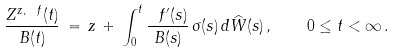Convert formula to latex. <formula><loc_0><loc_0><loc_500><loc_500>\frac { Z ^ { z , \ f } ( t ) } { B ( t ) } \, = \, z \, + \, \int _ { 0 } ^ { t } \frac { \ f ^ { \prime } ( s ) } { B ( s ) } \, \sigma ( s ) \, d \widehat { W } ( s ) \, , \quad 0 \leq t < \infty \, .</formula> 